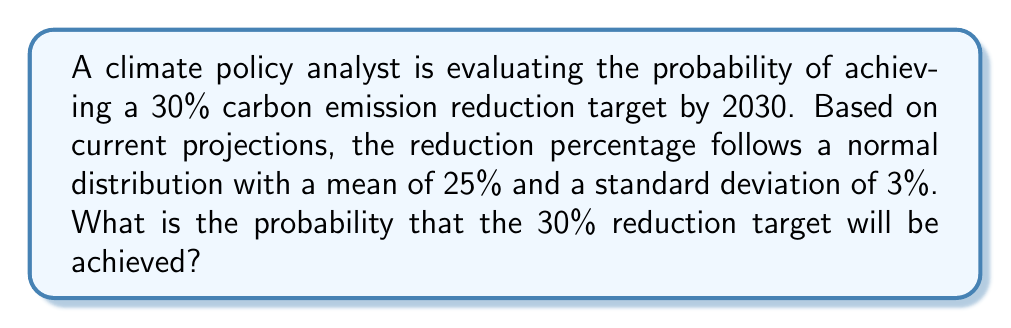Give your solution to this math problem. To solve this problem, we need to use the properties of the normal distribution and calculate the z-score for the target value. Then, we'll use a standard normal distribution table or a calculator to find the probability.

Step 1: Identify the given information
- The carbon emission reduction percentage follows a normal distribution
- Mean (μ) = 25%
- Standard deviation (σ) = 3%
- Target reduction = 30%

Step 2: Calculate the z-score
The z-score represents how many standard deviations the target value is from the mean.

$$ z = \frac{x - \mu}{\sigma} $$

Where:
x = target value
μ = mean
σ = standard deviation

$$ z = \frac{30 - 25}{3} = \frac{5}{3} \approx 1.67 $$

Step 3: Find the probability using the standard normal distribution
The z-score of 1.67 corresponds to the area to the left of the target value (30%) in the normal distribution curve. We need to find the area to the right of this value, which represents the probability of achieving the 30% reduction target or higher.

Area to the right = 1 - Area to the left

Using a standard normal distribution table or calculator:
Area to the left of z = 1.67 is approximately 0.9525

Therefore, the probability of achieving the target is:

$$ P(X \geq 30\%) = 1 - 0.9525 = 0.0475 $$

Step 4: Convert to percentage
0.0475 * 100 = 4.75%
Answer: 4.75% 